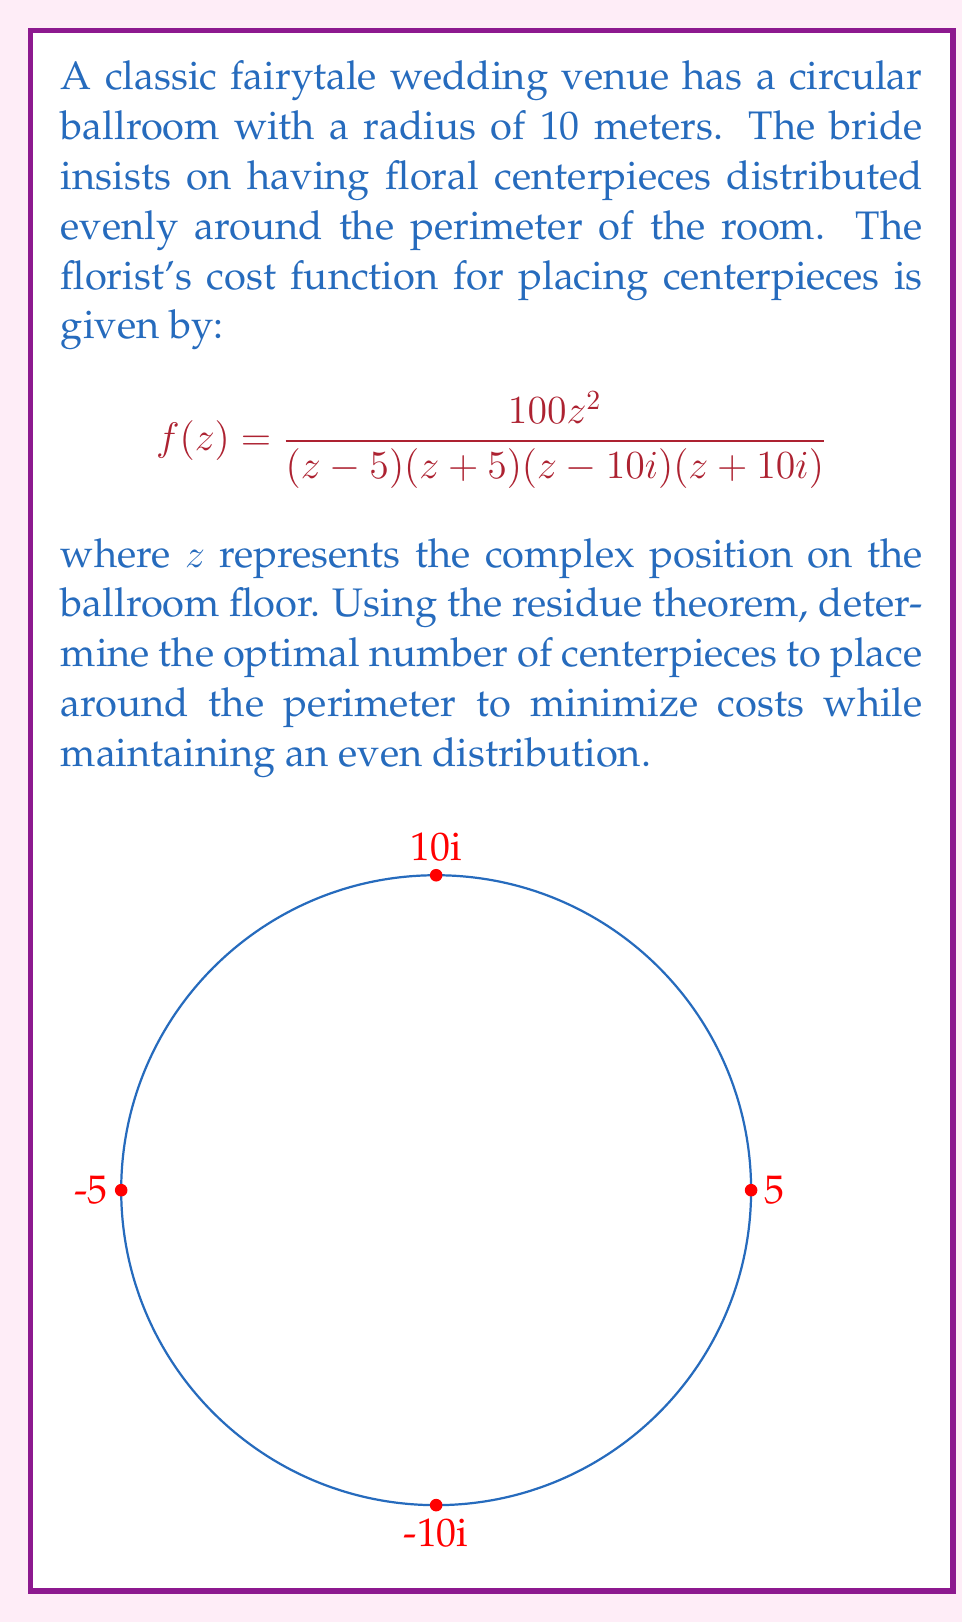Provide a solution to this math problem. To solve this problem, we'll use the residue theorem and analyze the poles of the given function.

Step 1: Identify the poles
The function $f(z)$ has four simple poles at $z = 5, -5, 10i, -10i$.

Step 2: Calculate residues
For a simple pole at $z = a$, the residue is given by:
$$\text{Res}(f, a) = \lim_{z \to a} (z-a)f(z)$$

For $z = 5$:
$$\text{Res}(f, 5) = \lim_{z \to 5} \frac{100z^2}{(z+5)(z-10i)(z+10i)} = \frac{2500}{400} = \frac{25}{4}$$

Due to symmetry, the residues at the other poles will be the same:
$$\text{Res}(f, -5) = \text{Res}(f, 10i) = \text{Res}(f, -10i) = \frac{25}{4}$$

Step 3: Apply the residue theorem
The residue theorem states that for a meromorphic function $f(z)$ inside and on a simple closed curve $C$:

$$\oint_C f(z) dz = 2\pi i \sum \text{Res}(f, a_k)$$

where $a_k$ are the poles of $f(z)$ inside $C$.

In our case, all four poles are inside the circle, so:

$$\oint_C f(z) dz = 2\pi i \left(\frac{25}{4} + \frac{25}{4} + \frac{25}{4} + \frac{25}{4}\right) = 2\pi i \cdot 25 = 50\pi i$$

Step 4: Interpret the result
The integral represents the total cost around the perimeter. To minimize costs while maintaining an even distribution, we should place centerpieces at positions corresponding to the poles.

Since there are four poles, the optimal number of centerpieces is 4, placed at the points corresponding to the poles: $(5,0)$, $(-5,0)$, $(0,10)$, and $(0,-10)$ in the complex plane.
Answer: 4 centerpieces 